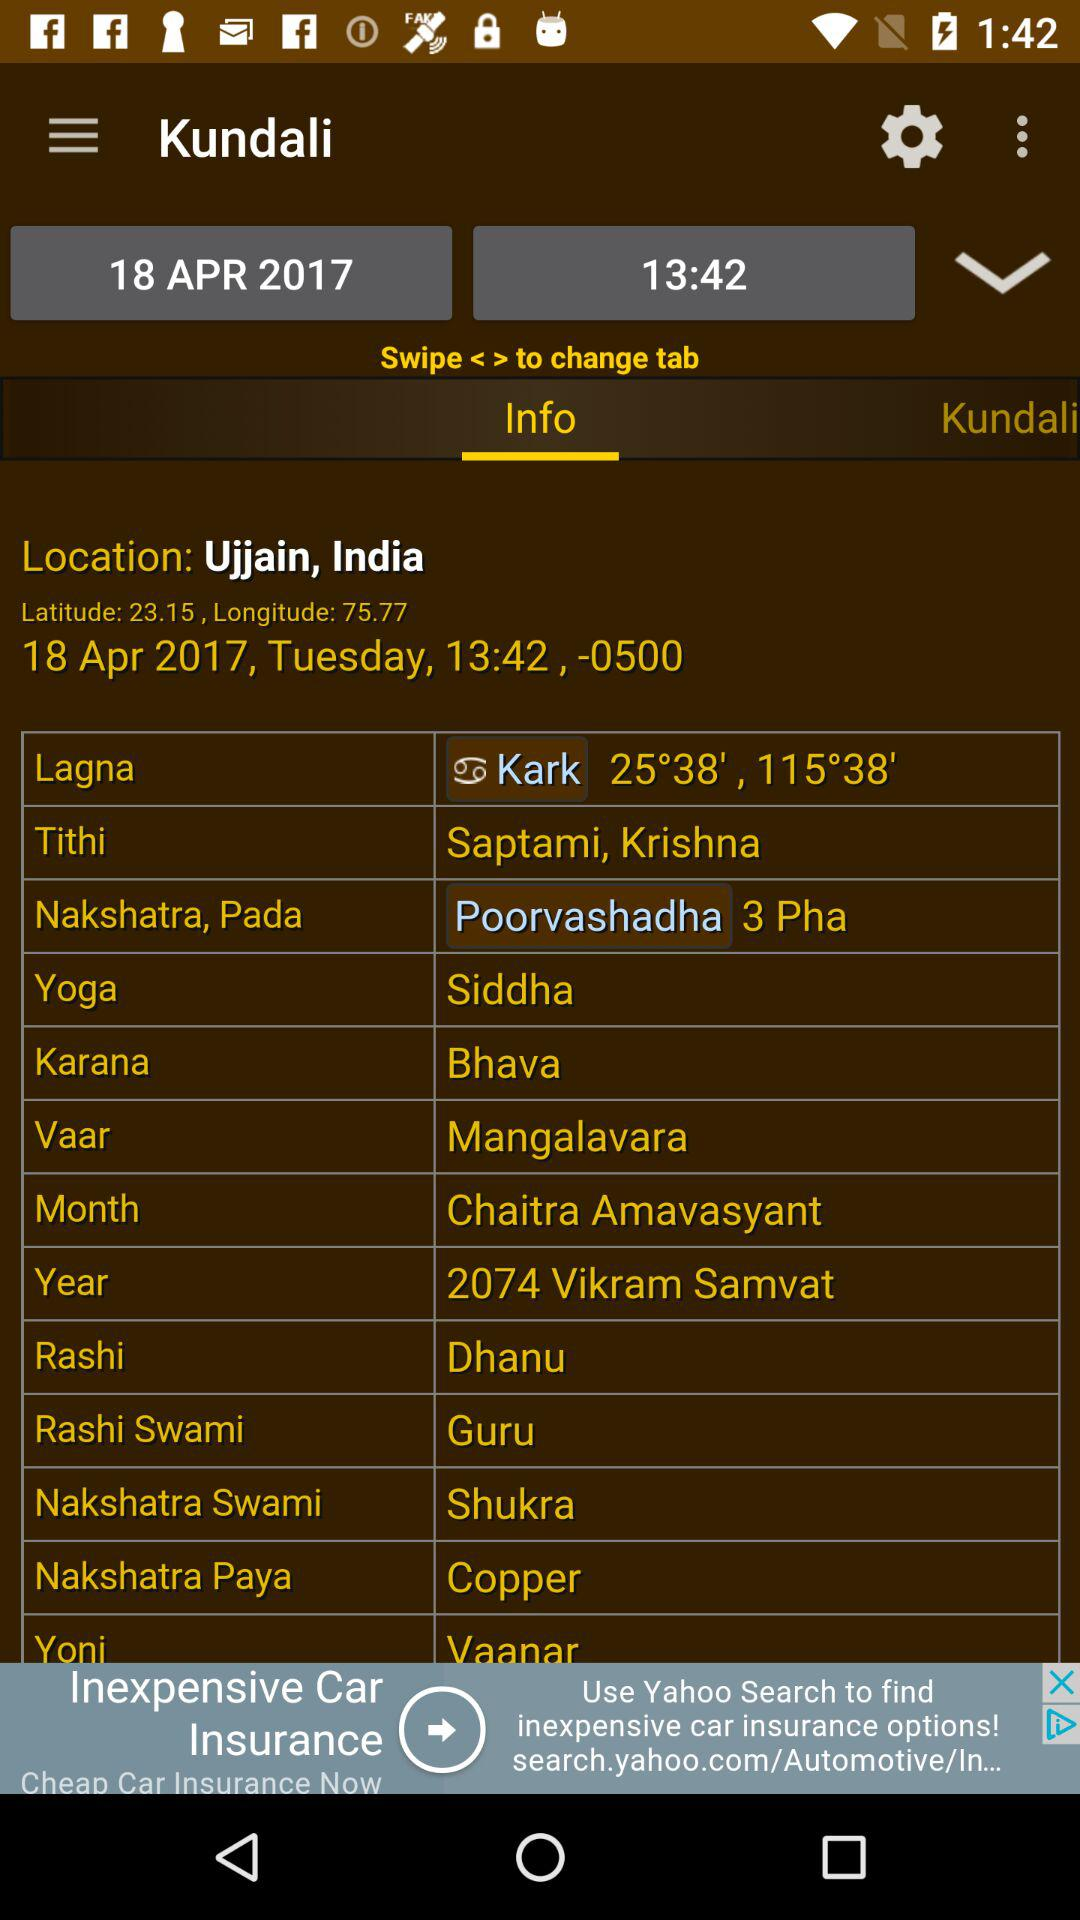What is "Yoga"?
Answer the question using a single word or phrase. "Yoga" is "Siddha". 